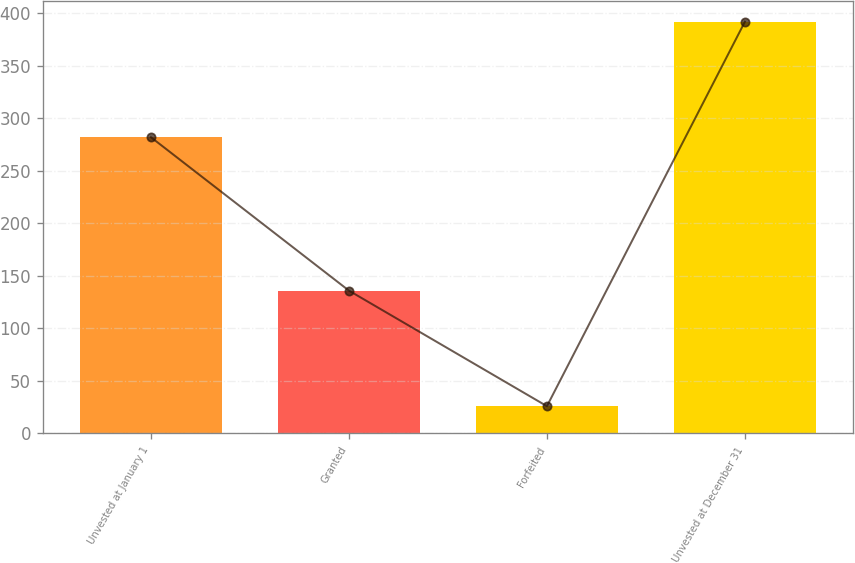<chart> <loc_0><loc_0><loc_500><loc_500><bar_chart><fcel>Unvested at January 1<fcel>Granted<fcel>Forfeited<fcel>Unvested at December 31<nl><fcel>282<fcel>136<fcel>26<fcel>392<nl></chart> 